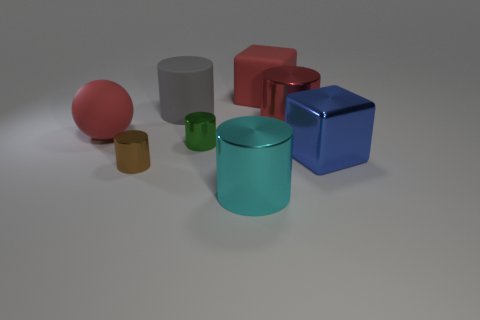How many cubes are the same color as the large rubber sphere?
Provide a short and direct response. 1. What material is the cube that is the same color as the rubber ball?
Provide a short and direct response. Rubber. There is a cylinder that is behind the red cylinder; what is its color?
Your response must be concise. Gray. There is a metal thing that is behind the small cylinder that is behind the blue block; what is its size?
Your response must be concise. Large. Does the big red matte object on the left side of the large cyan thing have the same shape as the tiny brown metallic object?
Offer a very short reply. No. What material is the red thing that is the same shape as the large gray rubber thing?
Ensure brevity in your answer.  Metal. How many things are either red things to the right of the gray object or large rubber objects to the right of the gray rubber thing?
Provide a succinct answer. 2. There is a ball; is its color the same as the large metallic cylinder that is on the right side of the big cyan shiny thing?
Ensure brevity in your answer.  Yes. There is a large blue thing that is the same material as the big red cylinder; what shape is it?
Your answer should be very brief. Cube. What number of big gray spheres are there?
Offer a very short reply. 0. 